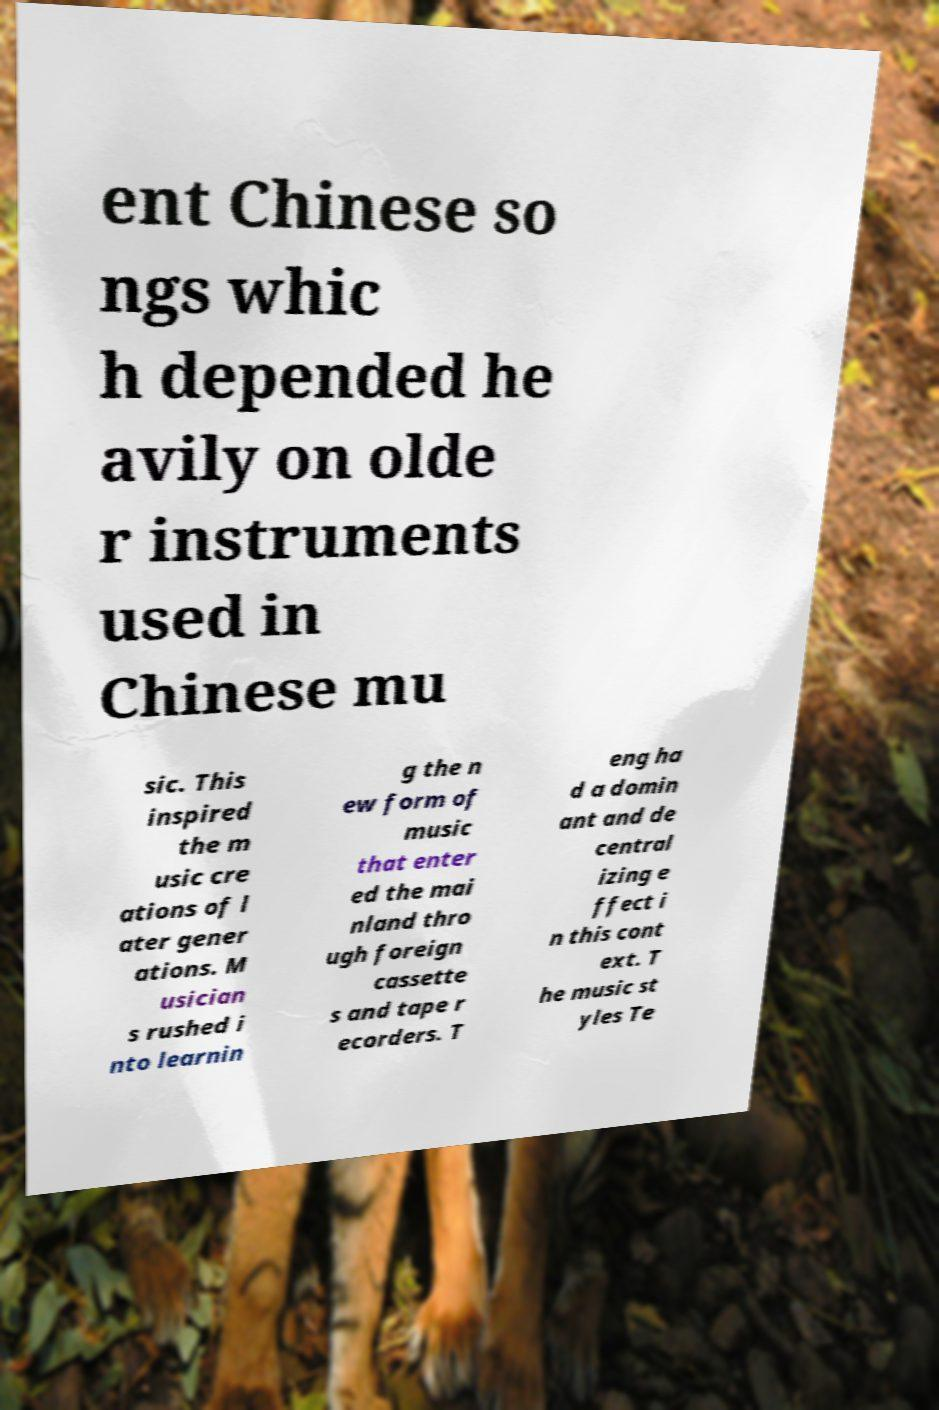For documentation purposes, I need the text within this image transcribed. Could you provide that? ent Chinese so ngs whic h depended he avily on olde r instruments used in Chinese mu sic. This inspired the m usic cre ations of l ater gener ations. M usician s rushed i nto learnin g the n ew form of music that enter ed the mai nland thro ugh foreign cassette s and tape r ecorders. T eng ha d a domin ant and de central izing e ffect i n this cont ext. T he music st yles Te 